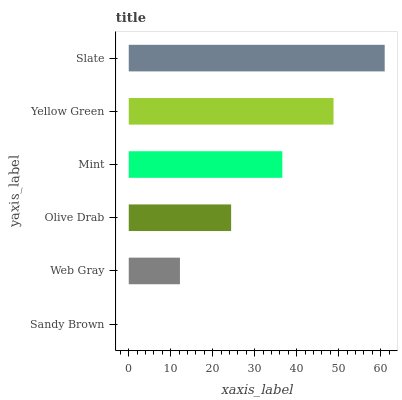Is Sandy Brown the minimum?
Answer yes or no. Yes. Is Slate the maximum?
Answer yes or no. Yes. Is Web Gray the minimum?
Answer yes or no. No. Is Web Gray the maximum?
Answer yes or no. No. Is Web Gray greater than Sandy Brown?
Answer yes or no. Yes. Is Sandy Brown less than Web Gray?
Answer yes or no. Yes. Is Sandy Brown greater than Web Gray?
Answer yes or no. No. Is Web Gray less than Sandy Brown?
Answer yes or no. No. Is Mint the high median?
Answer yes or no. Yes. Is Olive Drab the low median?
Answer yes or no. Yes. Is Olive Drab the high median?
Answer yes or no. No. Is Yellow Green the low median?
Answer yes or no. No. 